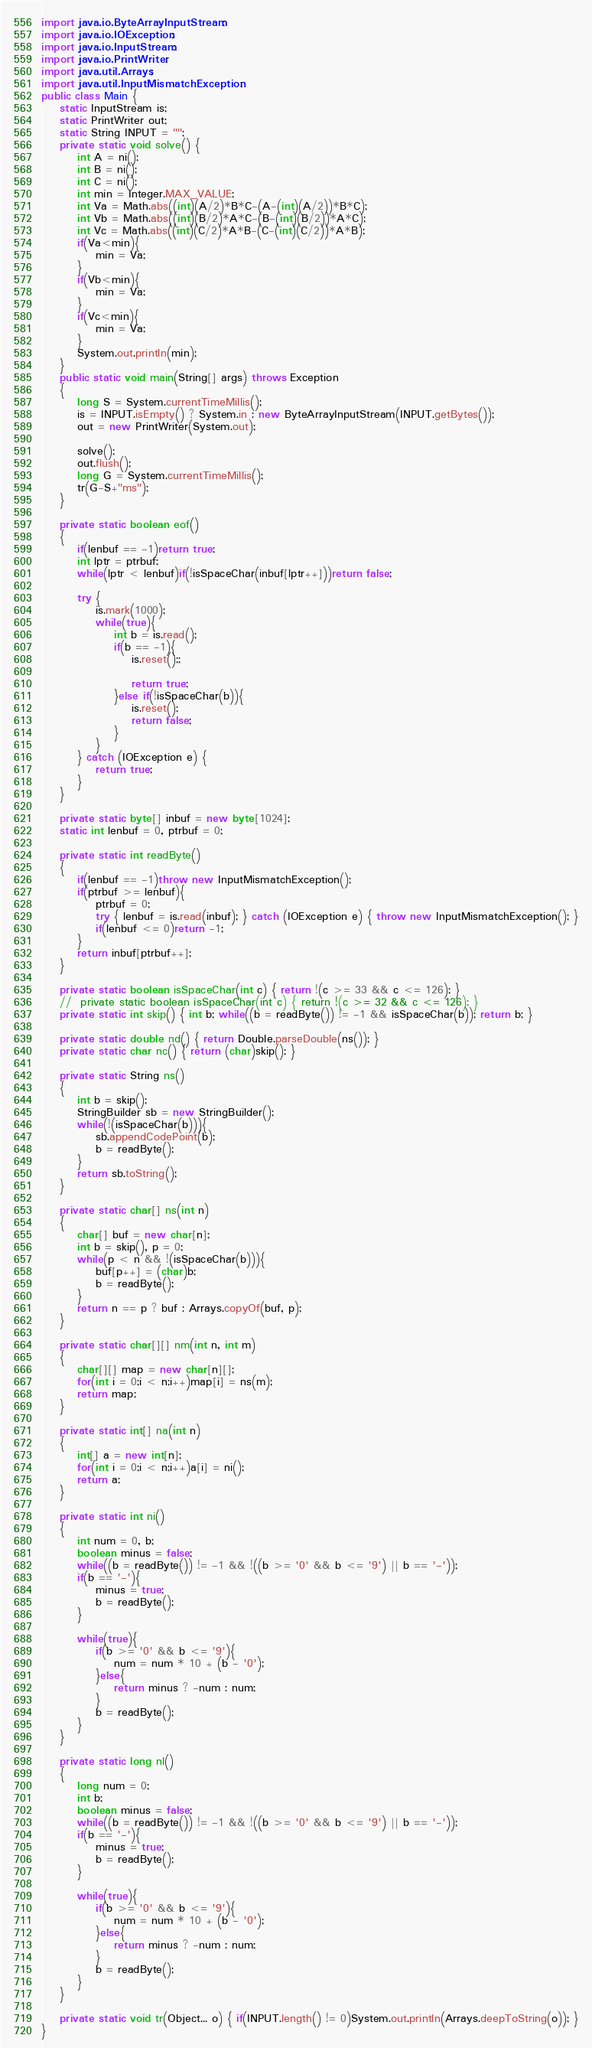<code> <loc_0><loc_0><loc_500><loc_500><_Java_>
import java.io.ByteArrayInputStream;
import java.io.IOException;
import java.io.InputStream;
import java.io.PrintWriter;
import java.util.Arrays;
import java.util.InputMismatchException;
public class Main {
	static InputStream is;
	static PrintWriter out;
	static String INPUT = "";
	private static void solve() {
		int A = ni();
		int B = ni();
		int C = ni();
		int min = Integer.MAX_VALUE;
		int Va = Math.abs((int)(A/2)*B*C-(A-(int)(A/2))*B*C);
		int Vb = Math.abs((int)(B/2)*A*C-(B-(int)(B/2))*A*C);
		int Vc = Math.abs((int)(C/2)*A*B-(C-(int)(C/2))*A*B);
		if(Va<min){
			min = Va;
		}
		if(Vb<min){
			min = Va;
		}
		if(Vc<min){
			min = Va;
		}
		System.out.println(min);
	}
	public static void main(String[] args) throws Exception
	{
		long S = System.currentTimeMillis();
		is = INPUT.isEmpty() ? System.in : new ByteArrayInputStream(INPUT.getBytes());
		out = new PrintWriter(System.out);

		solve();
		out.flush();
		long G = System.currentTimeMillis();
		tr(G-S+"ms");
	}

	private static boolean eof()
	{
		if(lenbuf == -1)return true;
		int lptr = ptrbuf;
		while(lptr < lenbuf)if(!isSpaceChar(inbuf[lptr++]))return false;

		try {
			is.mark(1000);
			while(true){
				int b = is.read();
				if(b == -1){
					is.reset();;

					return true;
				}else if(!isSpaceChar(b)){
					is.reset();
					return false;
				}
			}
		} catch (IOException e) {
			return true;
		}
	}

	private static byte[] inbuf = new byte[1024];
	static int lenbuf = 0, ptrbuf = 0;

	private static int readByte()
	{
		if(lenbuf == -1)throw new InputMismatchException();
		if(ptrbuf >= lenbuf){
			ptrbuf = 0;
			try { lenbuf = is.read(inbuf); } catch (IOException e) { throw new InputMismatchException(); }
			if(lenbuf <= 0)return -1;
		}
		return inbuf[ptrbuf++];
	}

	private static boolean isSpaceChar(int c) { return !(c >= 33 && c <= 126); }
	//	private static boolean isSpaceChar(int c) { return !(c >= 32 && c <= 126); }
	private static int skip() { int b; while((b = readByte()) != -1 && isSpaceChar(b)); return b; }

	private static double nd() { return Double.parseDouble(ns()); }
	private static char nc() { return (char)skip(); }

	private static String ns()
	{
		int b = skip();
		StringBuilder sb = new StringBuilder();
		while(!(isSpaceChar(b))){
			sb.appendCodePoint(b);
			b = readByte();
		}
		return sb.toString();
	}

	private static char[] ns(int n)
	{
		char[] buf = new char[n];
		int b = skip(), p = 0;
		while(p < n && !(isSpaceChar(b))){
			buf[p++] = (char)b;
			b = readByte();
		}
		return n == p ? buf : Arrays.copyOf(buf, p);
	}

	private static char[][] nm(int n, int m)
	{
		char[][] map = new char[n][];
		for(int i = 0;i < n;i++)map[i] = ns(m);
		return map;
	}

	private static int[] na(int n)
	{
		int[] a = new int[n];
		for(int i = 0;i < n;i++)a[i] = ni();
		return a;
	}

	private static int ni()
	{
		int num = 0, b;
		boolean minus = false;
		while((b = readByte()) != -1 && !((b >= '0' && b <= '9') || b == '-'));
		if(b == '-'){
			minus = true;
			b = readByte();
		}

		while(true){
			if(b >= '0' && b <= '9'){
				num = num * 10 + (b - '0');
			}else{
				return minus ? -num : num;
			}
			b = readByte();
		}
	}

	private static long nl()
	{
		long num = 0;
		int b;
		boolean minus = false;
		while((b = readByte()) != -1 && !((b >= '0' && b <= '9') || b == '-'));
		if(b == '-'){
			minus = true;
			b = readByte();
		}

		while(true){
			if(b >= '0' && b <= '9'){
				num = num * 10 + (b - '0');
			}else{
				return minus ? -num : num;
			}
			b = readByte();
		}
	}

	private static void tr(Object... o) { if(INPUT.length() != 0)System.out.println(Arrays.deepToString(o)); }
}
</code> 